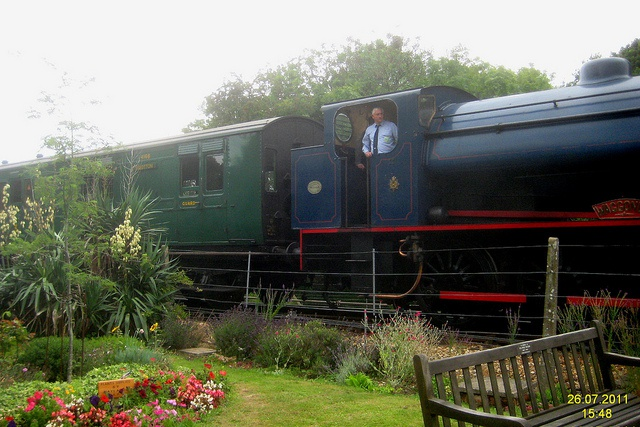Describe the objects in this image and their specific colors. I can see train in whitesmoke, black, gray, navy, and purple tones, bench in whitesmoke, black, darkgreen, and gray tones, people in whitesmoke, darkgray, and gray tones, and tie in whitesmoke, gray, darkblue, and navy tones in this image. 